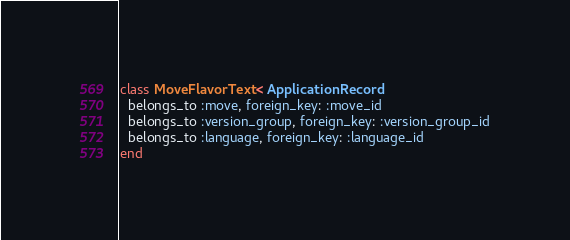Convert code to text. <code><loc_0><loc_0><loc_500><loc_500><_Ruby_>class MoveFlavorText < ApplicationRecord
  belongs_to :move, foreign_key: :move_id
  belongs_to :version_group, foreign_key: :version_group_id
  belongs_to :language, foreign_key: :language_id
end
</code> 